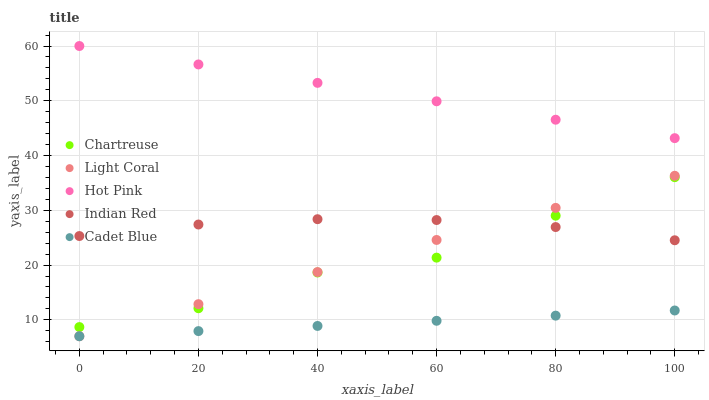Does Cadet Blue have the minimum area under the curve?
Answer yes or no. Yes. Does Hot Pink have the maximum area under the curve?
Answer yes or no. Yes. Does Chartreuse have the minimum area under the curve?
Answer yes or no. No. Does Chartreuse have the maximum area under the curve?
Answer yes or no. No. Is Light Coral the smoothest?
Answer yes or no. Yes. Is Chartreuse the roughest?
Answer yes or no. Yes. Is Hot Pink the smoothest?
Answer yes or no. No. Is Hot Pink the roughest?
Answer yes or no. No. Does Light Coral have the lowest value?
Answer yes or no. Yes. Does Chartreuse have the lowest value?
Answer yes or no. No. Does Hot Pink have the highest value?
Answer yes or no. Yes. Does Chartreuse have the highest value?
Answer yes or no. No. Is Cadet Blue less than Chartreuse?
Answer yes or no. Yes. Is Chartreuse greater than Cadet Blue?
Answer yes or no. Yes. Does Chartreuse intersect Indian Red?
Answer yes or no. Yes. Is Chartreuse less than Indian Red?
Answer yes or no. No. Is Chartreuse greater than Indian Red?
Answer yes or no. No. Does Cadet Blue intersect Chartreuse?
Answer yes or no. No. 